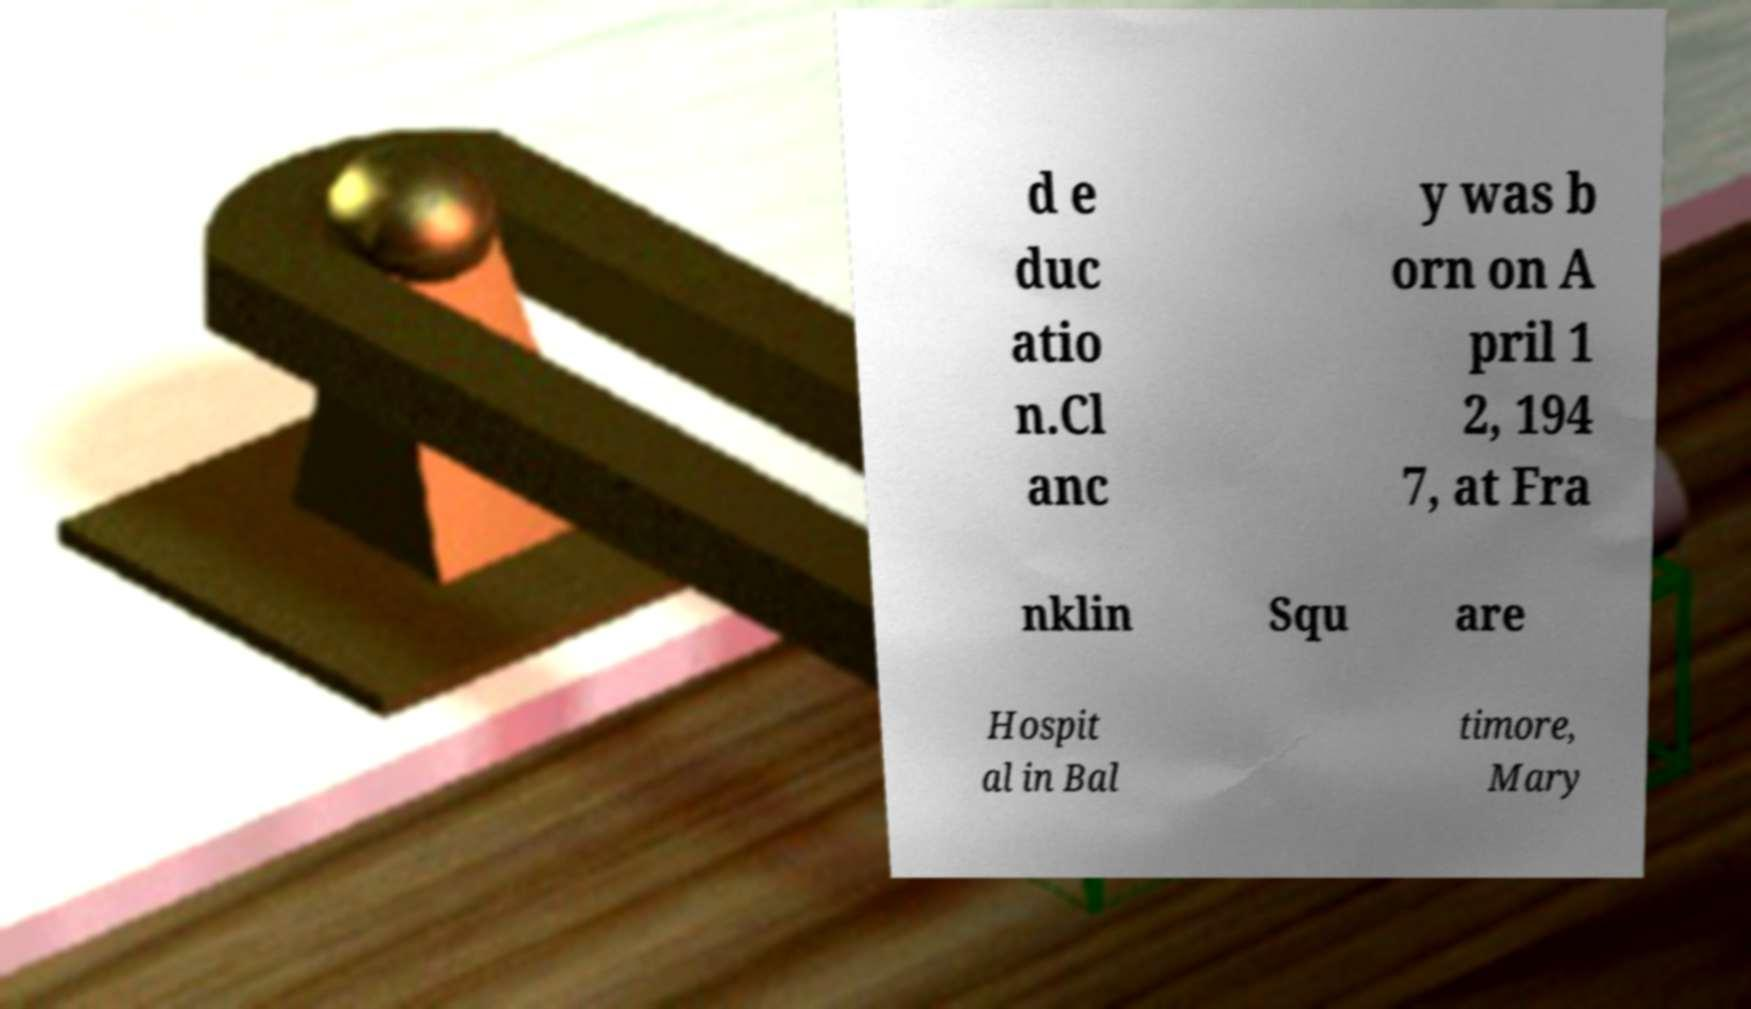There's text embedded in this image that I need extracted. Can you transcribe it verbatim? d e duc atio n.Cl anc y was b orn on A pril 1 2, 194 7, at Fra nklin Squ are Hospit al in Bal timore, Mary 